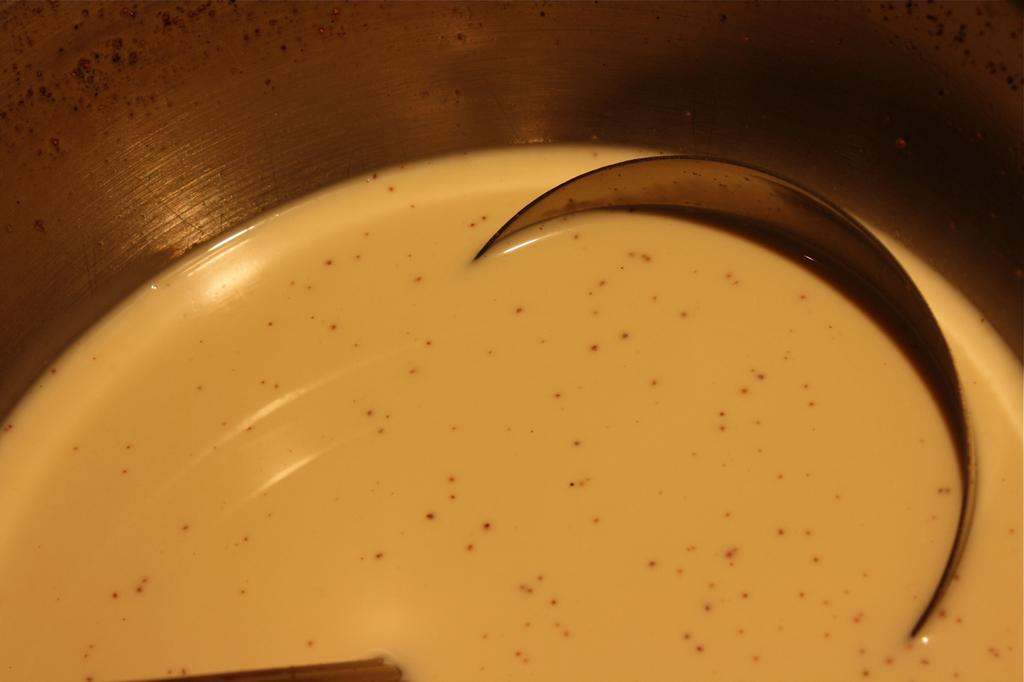What is the main subject in the foreground of the image? There is a liquid substance in the foreground of the image. What object is placed in the liquid substance? There is a spoon in the liquid substance. What part of the container holding the liquid substance is visible? The wall of the container is visible at the top of the image. Can you see any fingers using a crayon to draw on the wall of the container in the image? There are no fingers or crayons present in the image, and the wall of the container is not being used for drawing. 